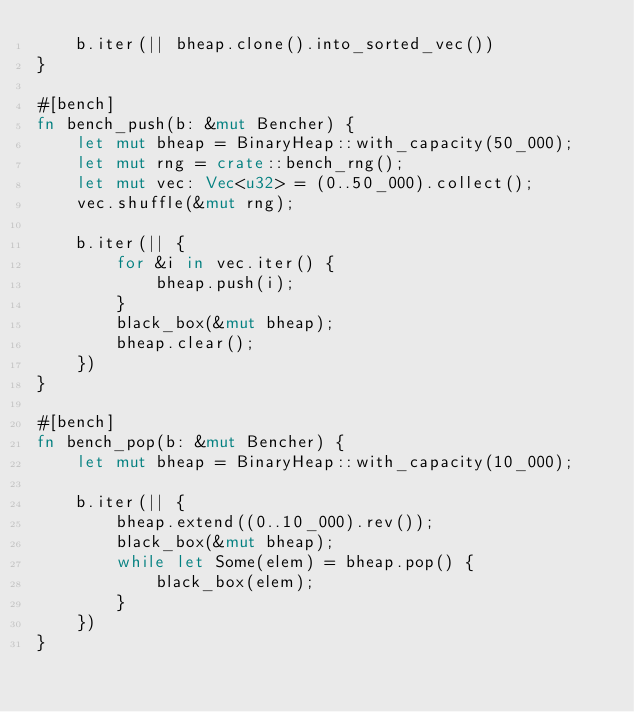Convert code to text. <code><loc_0><loc_0><loc_500><loc_500><_Rust_>    b.iter(|| bheap.clone().into_sorted_vec())
}

#[bench]
fn bench_push(b: &mut Bencher) {
    let mut bheap = BinaryHeap::with_capacity(50_000);
    let mut rng = crate::bench_rng();
    let mut vec: Vec<u32> = (0..50_000).collect();
    vec.shuffle(&mut rng);

    b.iter(|| {
        for &i in vec.iter() {
            bheap.push(i);
        }
        black_box(&mut bheap);
        bheap.clear();
    })
}

#[bench]
fn bench_pop(b: &mut Bencher) {
    let mut bheap = BinaryHeap::with_capacity(10_000);

    b.iter(|| {
        bheap.extend((0..10_000).rev());
        black_box(&mut bheap);
        while let Some(elem) = bheap.pop() {
            black_box(elem);
        }
    })
}
</code> 